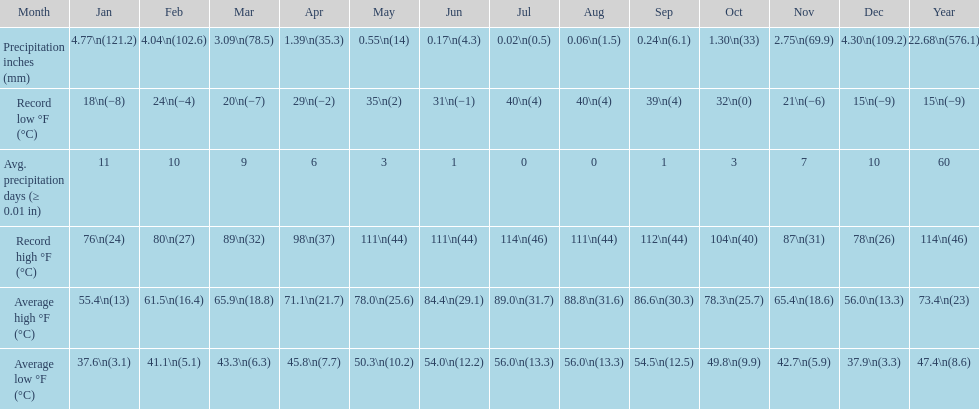Could you parse the entire table? {'header': ['Month', 'Jan', 'Feb', 'Mar', 'Apr', 'May', 'Jun', 'Jul', 'Aug', 'Sep', 'Oct', 'Nov', 'Dec', 'Year'], 'rows': [['Precipitation inches (mm)', '4.77\\n(121.2)', '4.04\\n(102.6)', '3.09\\n(78.5)', '1.39\\n(35.3)', '0.55\\n(14)', '0.17\\n(4.3)', '0.02\\n(0.5)', '0.06\\n(1.5)', '0.24\\n(6.1)', '1.30\\n(33)', '2.75\\n(69.9)', '4.30\\n(109.2)', '22.68\\n(576.1)'], ['Record low °F (°C)', '18\\n(−8)', '24\\n(−4)', '20\\n(−7)', '29\\n(−2)', '35\\n(2)', '31\\n(−1)', '40\\n(4)', '40\\n(4)', '39\\n(4)', '32\\n(0)', '21\\n(−6)', '15\\n(−9)', '15\\n(−9)'], ['Avg. precipitation days (≥ 0.01 in)', '11', '10', '9', '6', '3', '1', '0', '0', '1', '3', '7', '10', '60'], ['Record high °F (°C)', '76\\n(24)', '80\\n(27)', '89\\n(32)', '98\\n(37)', '111\\n(44)', '111\\n(44)', '114\\n(46)', '111\\n(44)', '112\\n(44)', '104\\n(40)', '87\\n(31)', '78\\n(26)', '114\\n(46)'], ['Average high °F (°C)', '55.4\\n(13)', '61.5\\n(16.4)', '65.9\\n(18.8)', '71.1\\n(21.7)', '78.0\\n(25.6)', '84.4\\n(29.1)', '89.0\\n(31.7)', '88.8\\n(31.6)', '86.6\\n(30.3)', '78.3\\n(25.7)', '65.4\\n(18.6)', '56.0\\n(13.3)', '73.4\\n(23)'], ['Average low °F (°C)', '37.6\\n(3.1)', '41.1\\n(5.1)', '43.3\\n(6.3)', '45.8\\n(7.7)', '50.3\\n(10.2)', '54.0\\n(12.2)', '56.0\\n(13.3)', '56.0\\n(13.3)', '54.5\\n(12.5)', '49.8\\n(9.9)', '42.7\\n(5.9)', '37.9\\n(3.3)', '47.4\\n(8.6)']]} How many months had a record high of 111 degrees? 3. 